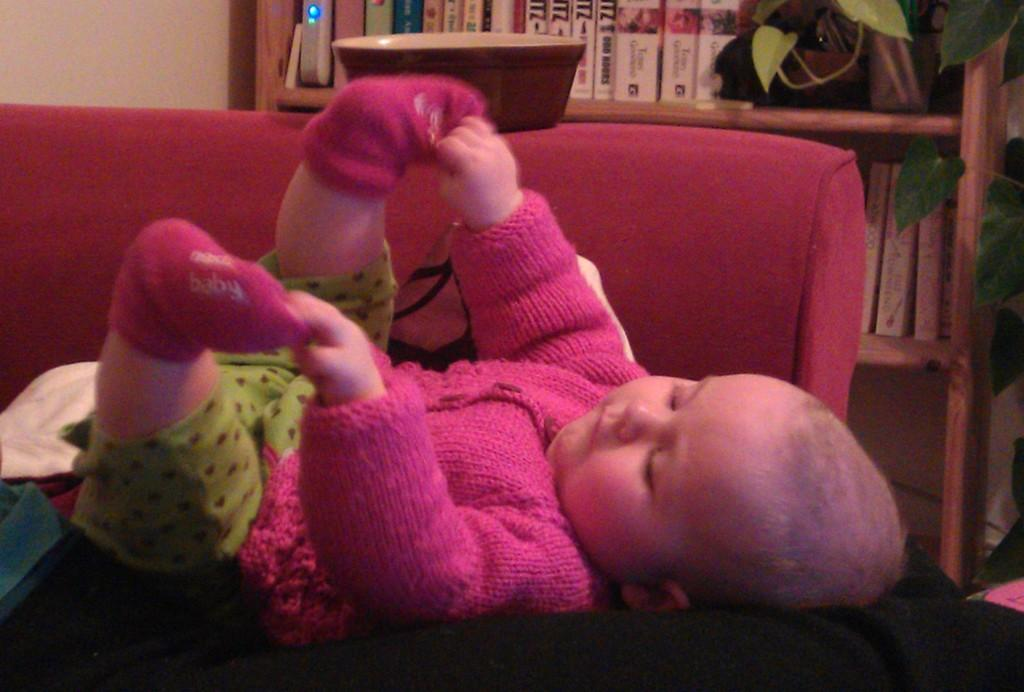What is in the image that can hold food or liquids? There is a bowl in the image. What is the baby doing in the image? The baby is lying on a couch. What can be seen behind the couch? There is an object and a house plant behind the couch. What type of vegetation is present in the image? There is a house plant in the image. What can be seen in the background of the image? There are books in racks and a wall in the background. How many snakes are crawling on the couch in the image? There are no snakes present in the image; the baby is lying on the couch. What type of chairs can be seen in the image? There are no chairs visible in the image. 